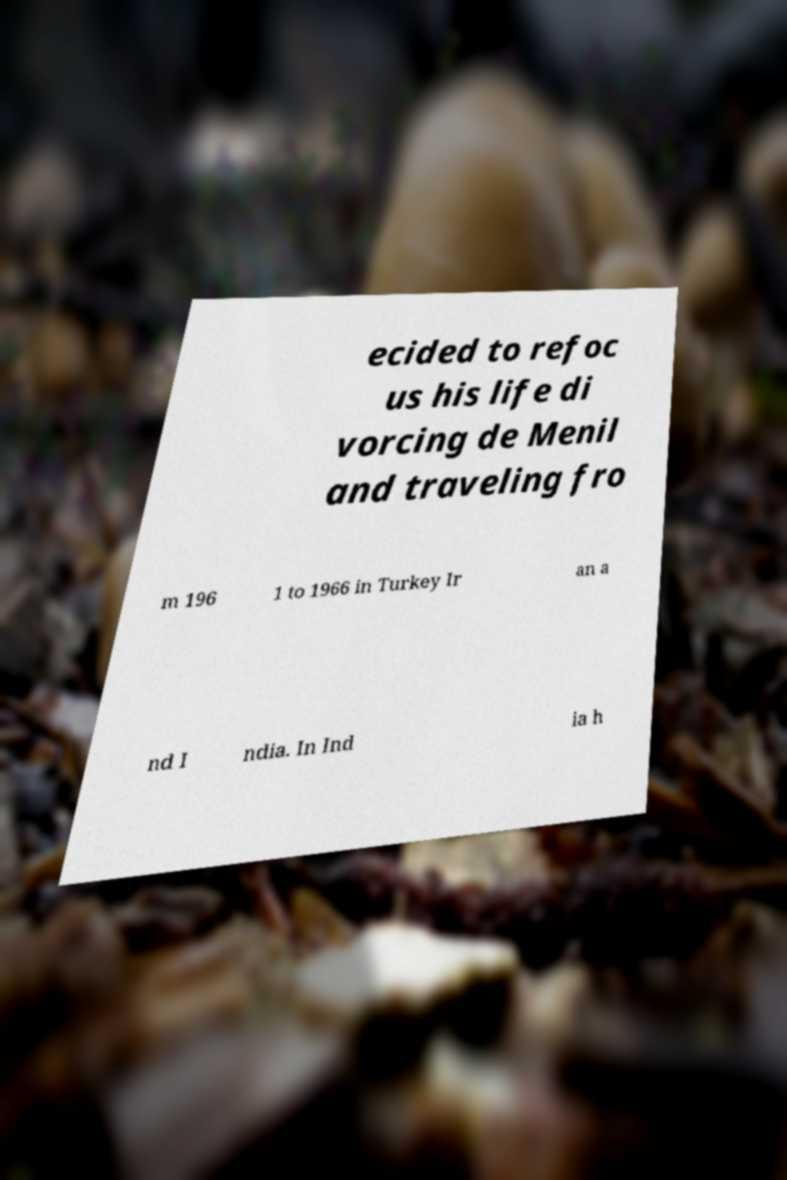I need the written content from this picture converted into text. Can you do that? ecided to refoc us his life di vorcing de Menil and traveling fro m 196 1 to 1966 in Turkey Ir an a nd I ndia. In Ind ia h 